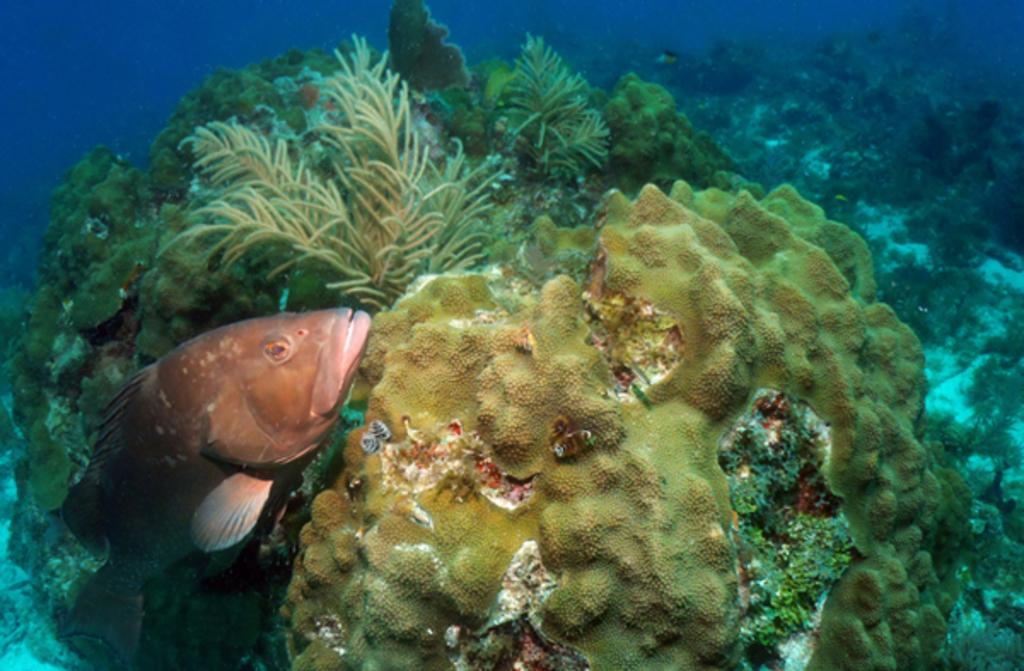What type of animal can be seen in the water on the left side of the image? There is a fish in the water on the left side of the image. What else can be seen in the background of the image? There are aquatic plants present in the background of the image. Where is the beggar located in the image? There is no beggar present in the image. What type of hill can be seen in the background of the image? There is no hill present in the image; it features water and aquatic plants. 